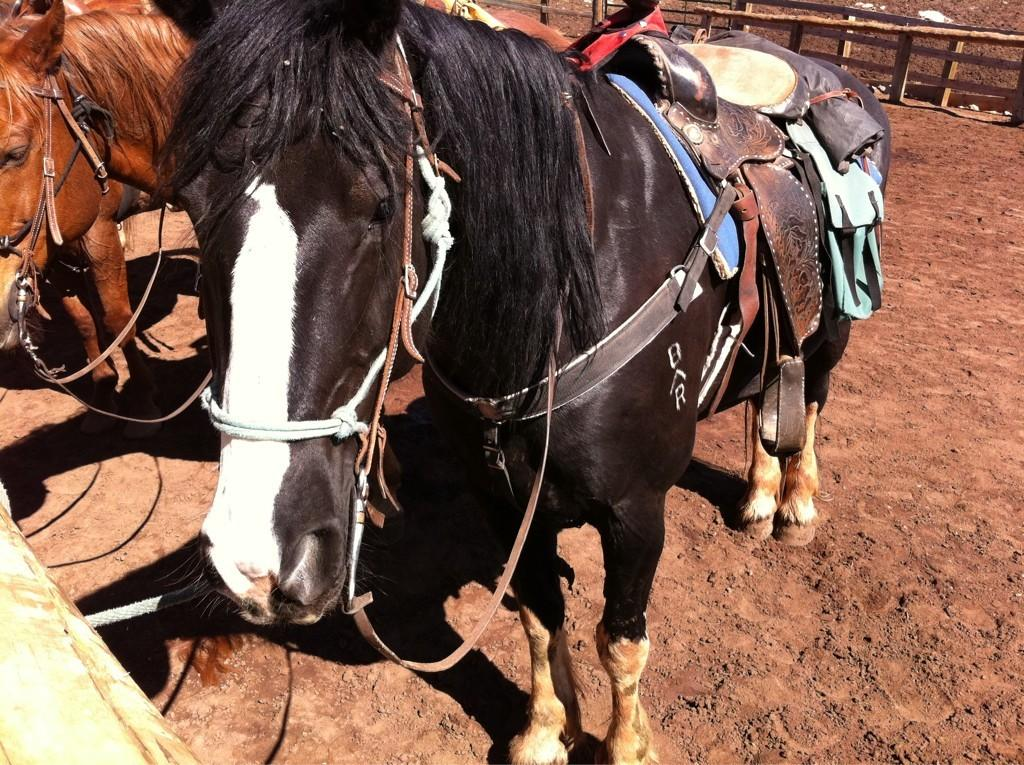How many horses are in the image? There are two horses in the image. What is the position of the horses in the image? The horses are standing on the ground. What can be seen in the background of the image? There is wooden fencing in the background of the image. What type of mist is covering the horses in the image? There is no mist present in the image; the horses are standing on the ground with clear visibility. 